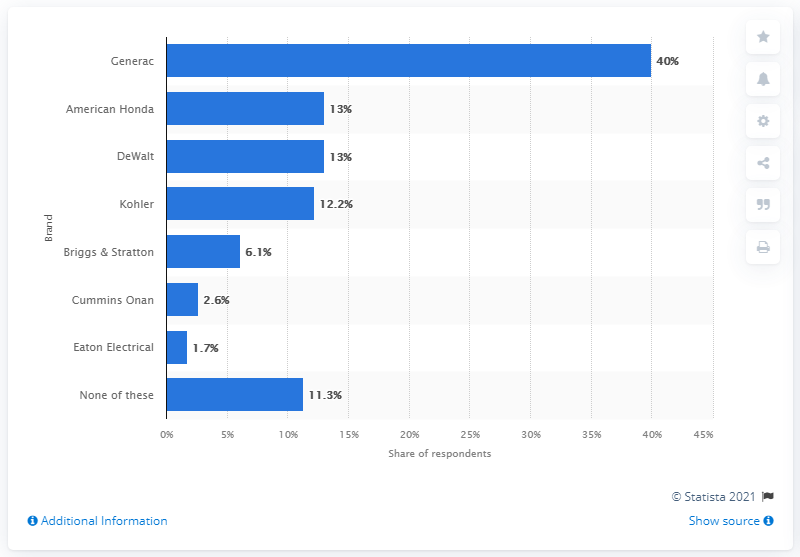Point out several critical features in this image. According to the survey, 40% of respondents reported using Generac portable generators the most. 